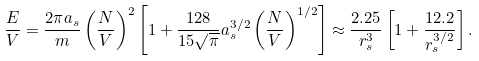<formula> <loc_0><loc_0><loc_500><loc_500>\frac { E } { V } = \frac { 2 \pi a _ { s } } { m } \left ( \frac { N } { V } \right ) ^ { 2 } \left [ 1 + \frac { 1 2 8 } { 1 5 \sqrt { \pi } } a _ { s } ^ { 3 / 2 } \left ( \frac { N } { V } \right ) ^ { 1 / 2 } \right ] \approx \frac { 2 . 2 5 } { r _ { s } ^ { 3 } } \left [ 1 + \frac { 1 2 . 2 } { r _ { s } ^ { 3 / 2 } } \right ] .</formula> 